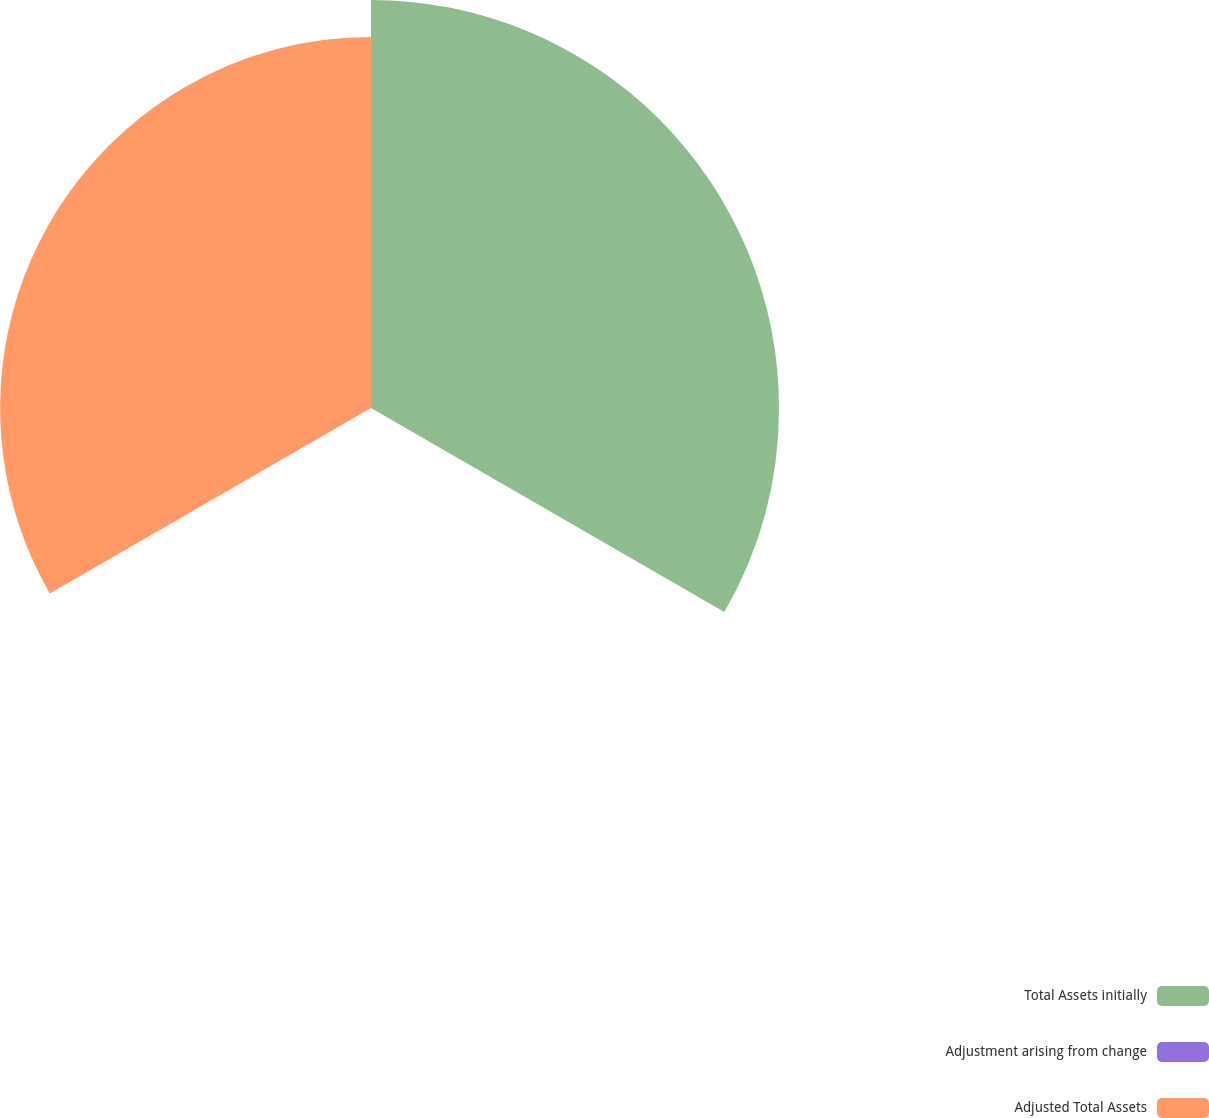<chart> <loc_0><loc_0><loc_500><loc_500><pie_chart><fcel>Total Assets initially<fcel>Adjustment arising from change<fcel>Adjusted Total Assets<nl><fcel>52.34%<fcel>0.07%<fcel>47.58%<nl></chart> 